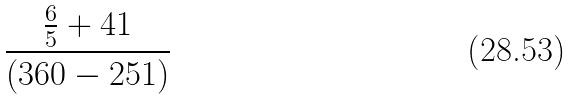<formula> <loc_0><loc_0><loc_500><loc_500>\frac { \frac { 6 } { 5 } + 4 1 } { ( 3 6 0 - 2 5 1 ) }</formula> 